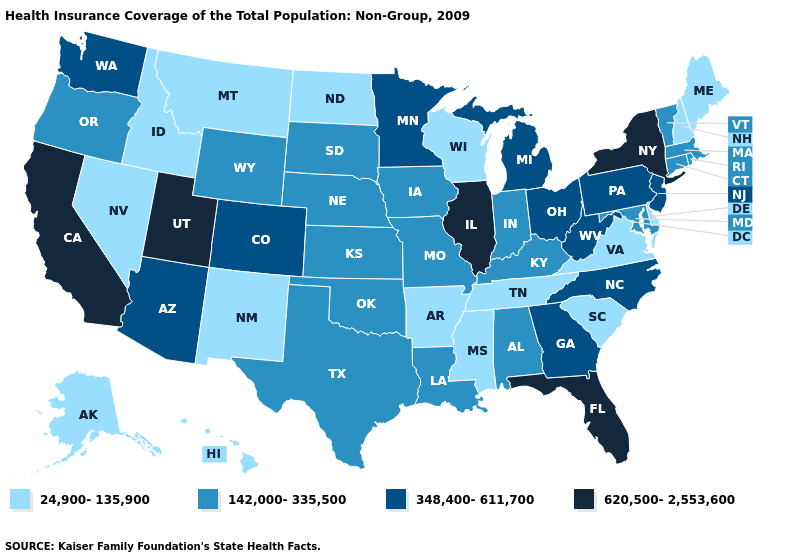Is the legend a continuous bar?
Answer briefly. No. What is the lowest value in the USA?
Short answer required. 24,900-135,900. Does the map have missing data?
Give a very brief answer. No. Among the states that border Colorado , which have the highest value?
Keep it brief. Utah. Name the states that have a value in the range 24,900-135,900?
Write a very short answer. Alaska, Arkansas, Delaware, Hawaii, Idaho, Maine, Mississippi, Montana, Nevada, New Hampshire, New Mexico, North Dakota, South Carolina, Tennessee, Virginia, Wisconsin. Name the states that have a value in the range 620,500-2,553,600?
Quick response, please. California, Florida, Illinois, New York, Utah. Does Indiana have a lower value than Georgia?
Short answer required. Yes. What is the highest value in the USA?
Concise answer only. 620,500-2,553,600. Name the states that have a value in the range 142,000-335,500?
Short answer required. Alabama, Connecticut, Indiana, Iowa, Kansas, Kentucky, Louisiana, Maryland, Massachusetts, Missouri, Nebraska, Oklahoma, Oregon, Rhode Island, South Dakota, Texas, Vermont, Wyoming. Among the states that border Kentucky , which have the lowest value?
Answer briefly. Tennessee, Virginia. Does Illinois have the highest value in the USA?
Answer briefly. Yes. How many symbols are there in the legend?
Keep it brief. 4. Name the states that have a value in the range 620,500-2,553,600?
Quick response, please. California, Florida, Illinois, New York, Utah. Name the states that have a value in the range 142,000-335,500?
Answer briefly. Alabama, Connecticut, Indiana, Iowa, Kansas, Kentucky, Louisiana, Maryland, Massachusetts, Missouri, Nebraska, Oklahoma, Oregon, Rhode Island, South Dakota, Texas, Vermont, Wyoming. Name the states that have a value in the range 24,900-135,900?
Keep it brief. Alaska, Arkansas, Delaware, Hawaii, Idaho, Maine, Mississippi, Montana, Nevada, New Hampshire, New Mexico, North Dakota, South Carolina, Tennessee, Virginia, Wisconsin. 